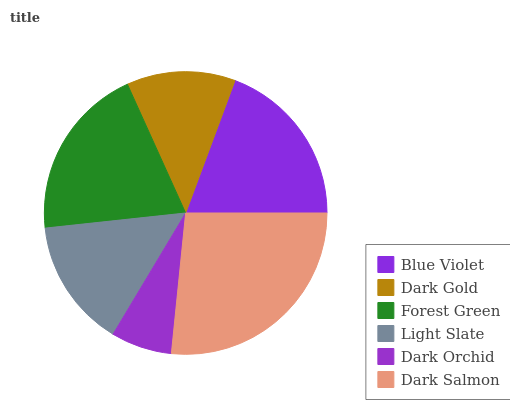Is Dark Orchid the minimum?
Answer yes or no. Yes. Is Dark Salmon the maximum?
Answer yes or no. Yes. Is Dark Gold the minimum?
Answer yes or no. No. Is Dark Gold the maximum?
Answer yes or no. No. Is Blue Violet greater than Dark Gold?
Answer yes or no. Yes. Is Dark Gold less than Blue Violet?
Answer yes or no. Yes. Is Dark Gold greater than Blue Violet?
Answer yes or no. No. Is Blue Violet less than Dark Gold?
Answer yes or no. No. Is Blue Violet the high median?
Answer yes or no. Yes. Is Light Slate the low median?
Answer yes or no. Yes. Is Forest Green the high median?
Answer yes or no. No. Is Blue Violet the low median?
Answer yes or no. No. 